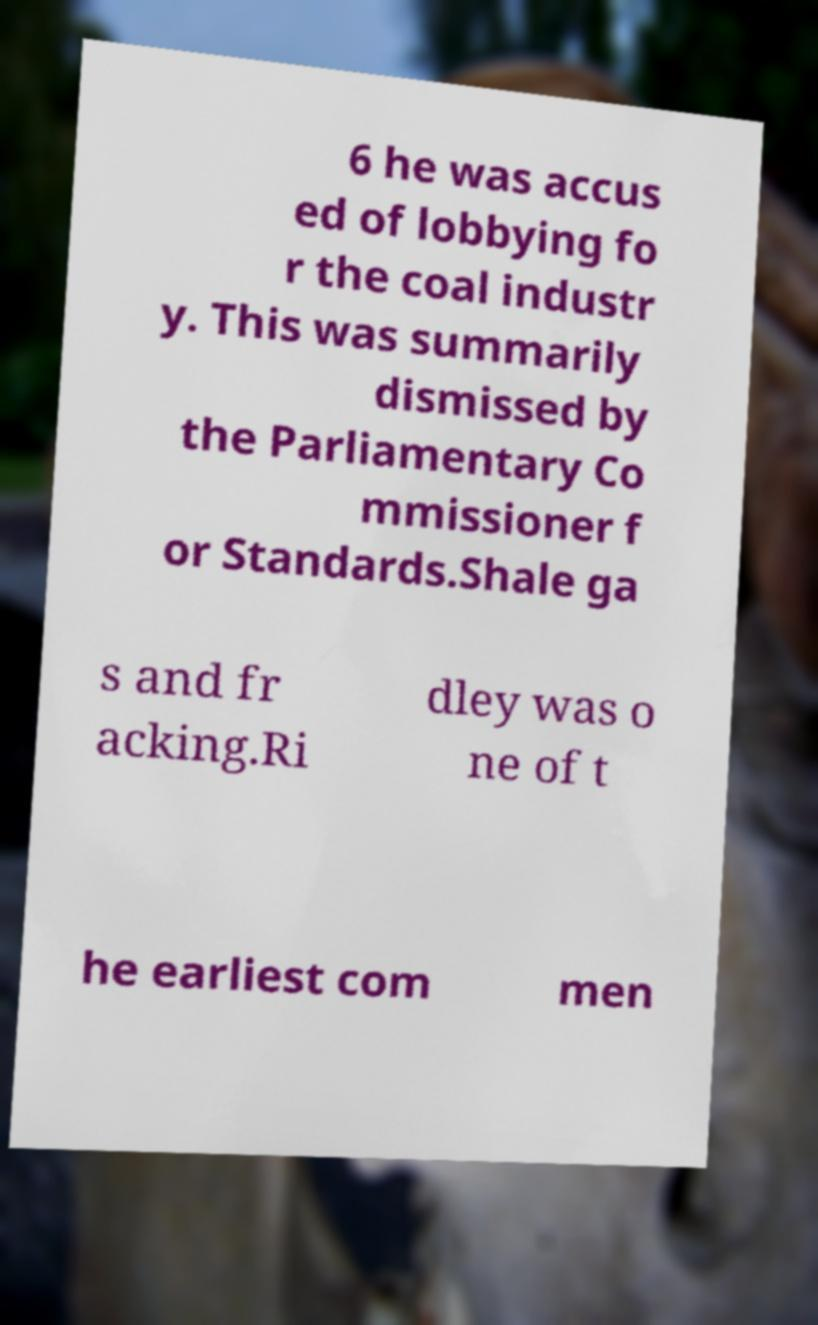Can you read and provide the text displayed in the image?This photo seems to have some interesting text. Can you extract and type it out for me? 6 he was accus ed of lobbying fo r the coal industr y. This was summarily dismissed by the Parliamentary Co mmissioner f or Standards.Shale ga s and fr acking.Ri dley was o ne of t he earliest com men 